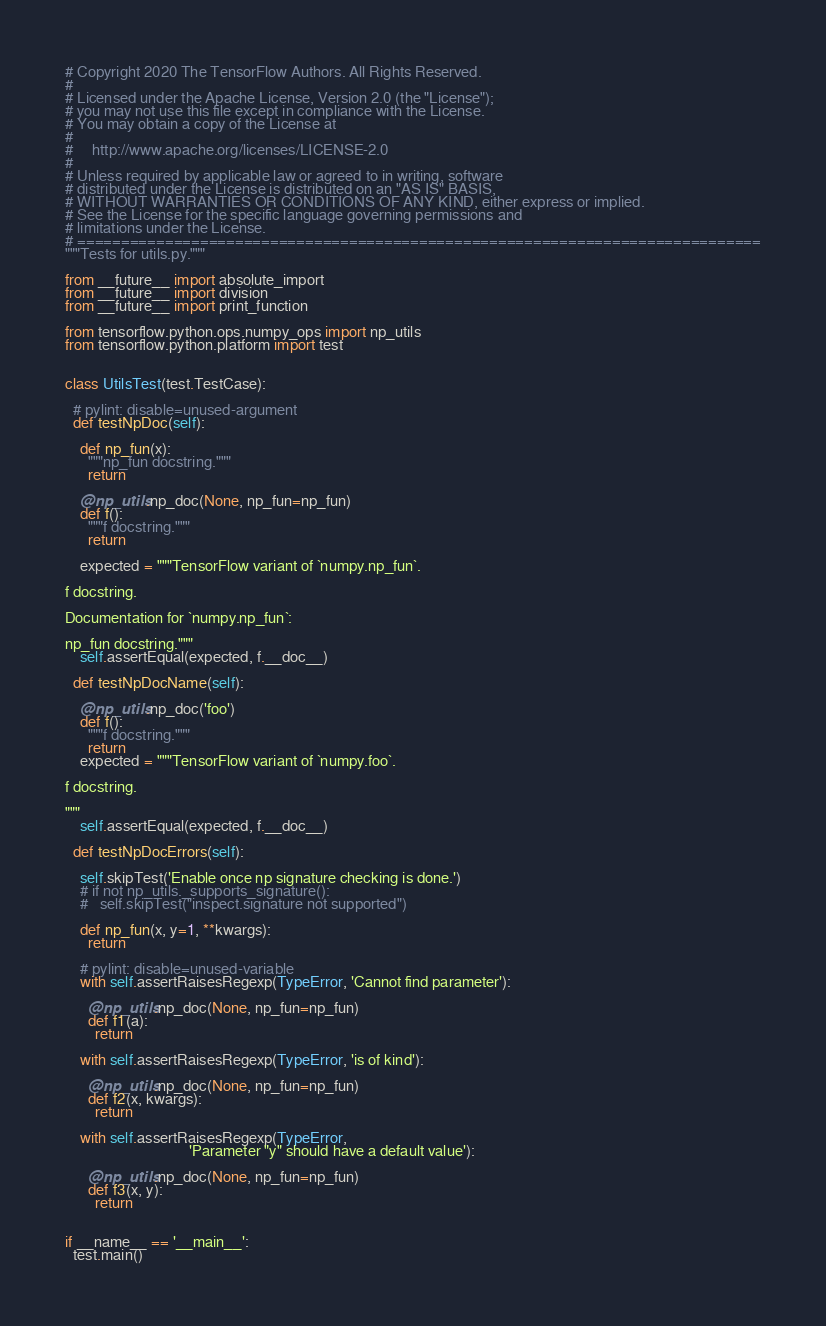Convert code to text. <code><loc_0><loc_0><loc_500><loc_500><_Python_># Copyright 2020 The TensorFlow Authors. All Rights Reserved.
#
# Licensed under the Apache License, Version 2.0 (the "License");
# you may not use this file except in compliance with the License.
# You may obtain a copy of the License at
#
#     http://www.apache.org/licenses/LICENSE-2.0
#
# Unless required by applicable law or agreed to in writing, software
# distributed under the License is distributed on an "AS IS" BASIS,
# WITHOUT WARRANTIES OR CONDITIONS OF ANY KIND, either express or implied.
# See the License for the specific language governing permissions and
# limitations under the License.
# ==============================================================================
"""Tests for utils.py."""

from __future__ import absolute_import
from __future__ import division
from __future__ import print_function

from tensorflow.python.ops.numpy_ops import np_utils
from tensorflow.python.platform import test


class UtilsTest(test.TestCase):

  # pylint: disable=unused-argument
  def testNpDoc(self):

    def np_fun(x):
      """np_fun docstring."""
      return

    @np_utils.np_doc(None, np_fun=np_fun)
    def f():
      """f docstring."""
      return

    expected = """TensorFlow variant of `numpy.np_fun`.

f docstring.

Documentation for `numpy.np_fun`:

np_fun docstring."""
    self.assertEqual(expected, f.__doc__)

  def testNpDocName(self):

    @np_utils.np_doc('foo')
    def f():
      """f docstring."""
      return
    expected = """TensorFlow variant of `numpy.foo`.

f docstring.

"""
    self.assertEqual(expected, f.__doc__)

  def testNpDocErrors(self):

    self.skipTest('Enable once np signature checking is done.')
    # if not np_utils._supports_signature():
    #   self.skipTest("inspect.signature not supported")

    def np_fun(x, y=1, **kwargs):
      return

    # pylint: disable=unused-variable
    with self.assertRaisesRegexp(TypeError, 'Cannot find parameter'):

      @np_utils.np_doc(None, np_fun=np_fun)
      def f1(a):
        return

    with self.assertRaisesRegexp(TypeError, 'is of kind'):

      @np_utils.np_doc(None, np_fun=np_fun)
      def f2(x, kwargs):
        return

    with self.assertRaisesRegexp(TypeError,
                                 'Parameter "y" should have a default value'):

      @np_utils.np_doc(None, np_fun=np_fun)
      def f3(x, y):
        return


if __name__ == '__main__':
  test.main()
</code> 